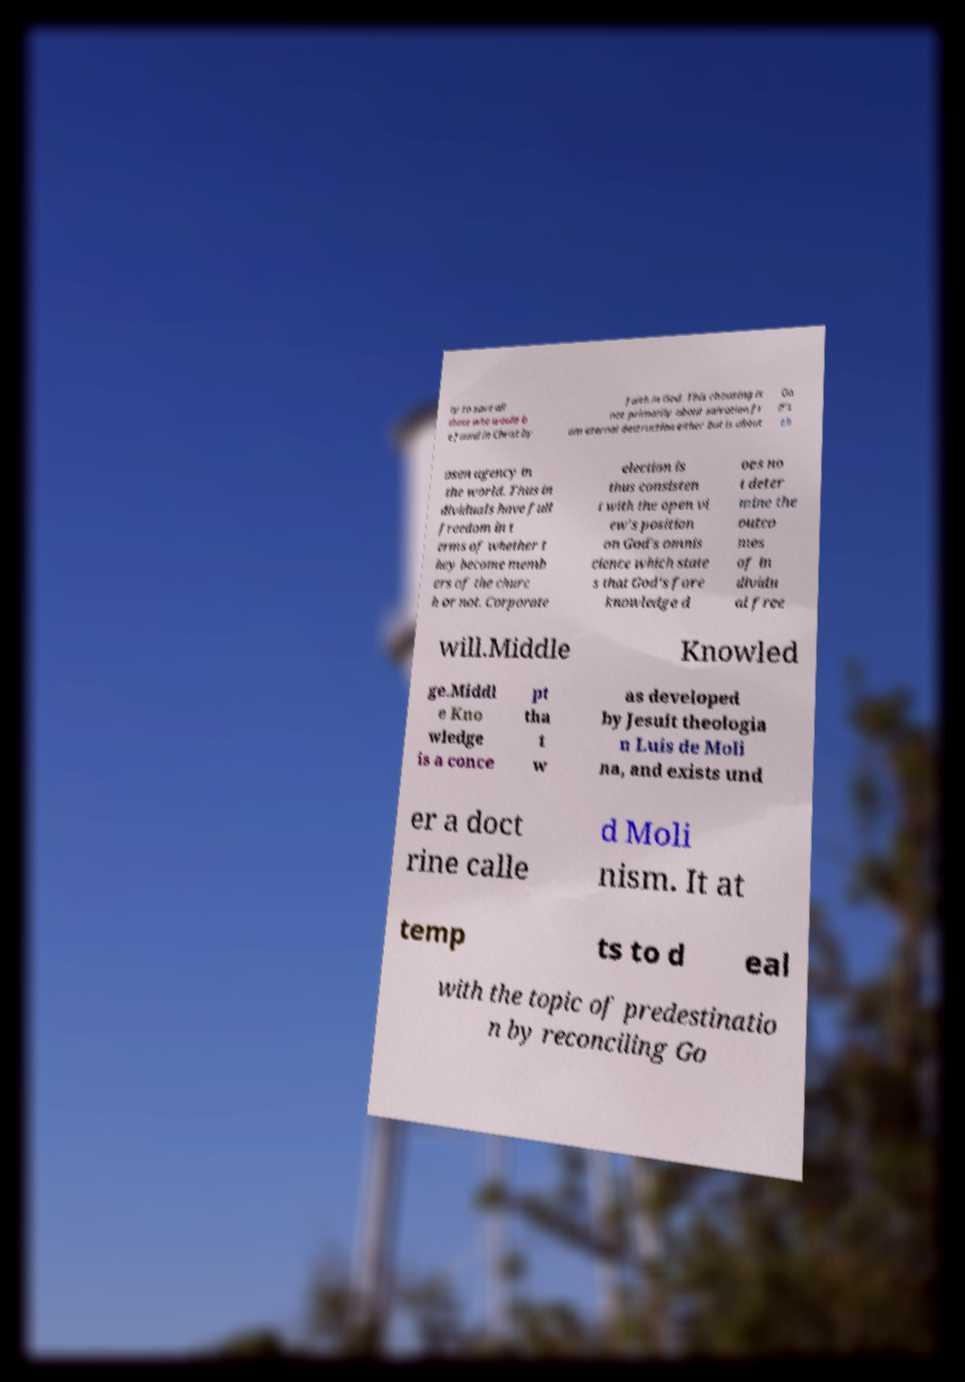Could you assist in decoding the text presented in this image and type it out clearly? ty to save all those who would b e found in Christ by faith in God. This choosing is not primarily about salvation fr om eternal destruction either but is about Go d's ch osen agency in the world. Thus in dividuals have full freedom in t erms of whether t hey become memb ers of the churc h or not. Corporate election is thus consisten t with the open vi ew's position on God's omnis cience which state s that God's fore knowledge d oes no t deter mine the outco mes of in dividu al free will.Middle Knowled ge.Middl e Kno wledge is a conce pt tha t w as developed by Jesuit theologia n Luis de Moli na, and exists und er a doct rine calle d Moli nism. It at temp ts to d eal with the topic of predestinatio n by reconciling Go 